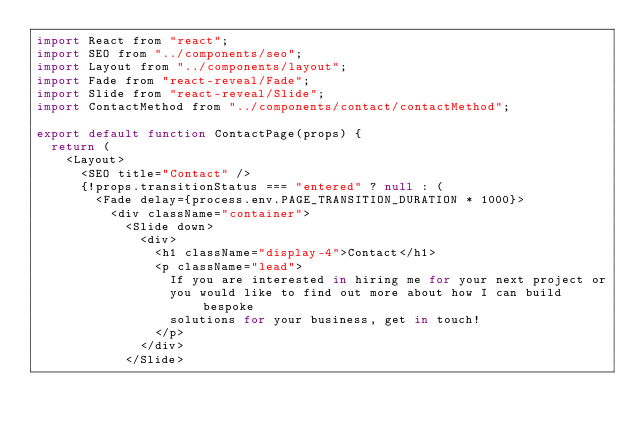Convert code to text. <code><loc_0><loc_0><loc_500><loc_500><_JavaScript_>import React from "react";
import SEO from "../components/seo";
import Layout from "../components/layout";
import Fade from "react-reveal/Fade";
import Slide from "react-reveal/Slide";
import ContactMethod from "../components/contact/contactMethod";

export default function ContactPage(props) {
  return (
    <Layout>
      <SEO title="Contact" />
      {!props.transitionStatus === "entered" ? null : (
        <Fade delay={process.env.PAGE_TRANSITION_DURATION * 1000}>
          <div className="container">
            <Slide down>
              <div>
                <h1 className="display-4">Contact</h1>
                <p className="lead">
                  If you are interested in hiring me for your next project or
                  you would like to find out more about how I can build bespoke
                  solutions for your business, get in touch!
                </p>
              </div>
            </Slide></code> 